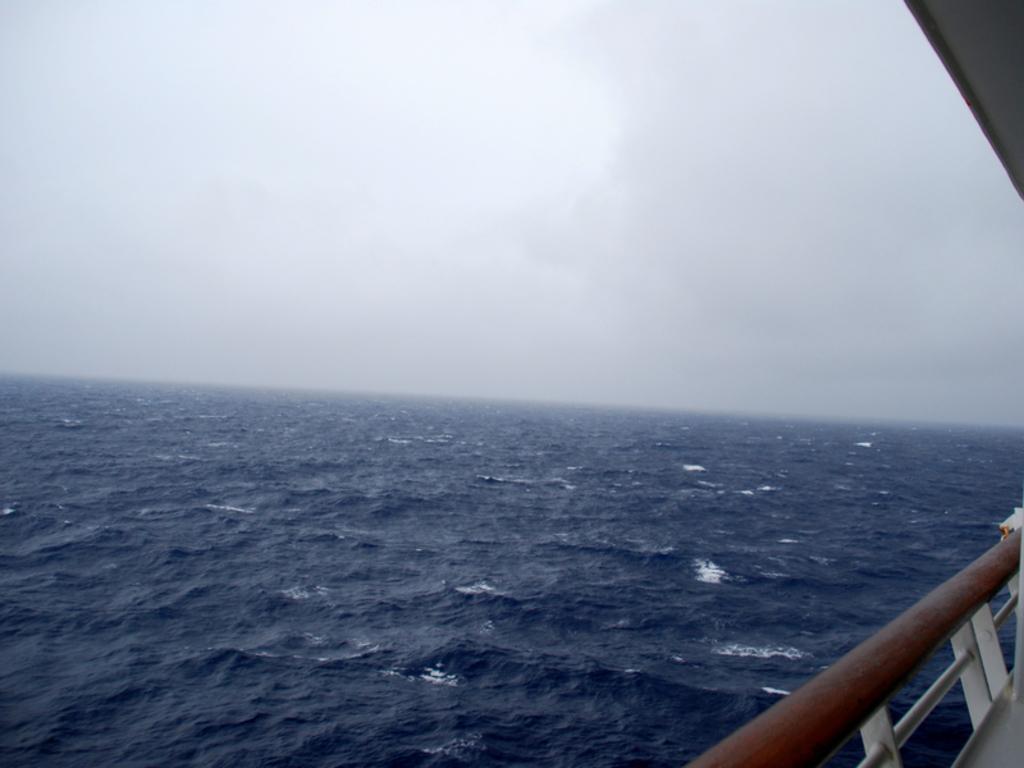Describe this image in one or two sentences. On the right there is a fence made with metal. In the background we can see water and sky. On the right at the top corner there is an object. 